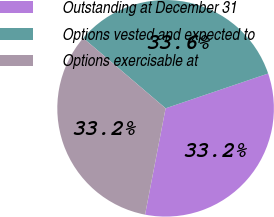Convert chart. <chart><loc_0><loc_0><loc_500><loc_500><pie_chart><fcel>Outstanding at December 31<fcel>Options vested and expected to<fcel>Options exercisable at<nl><fcel>33.24%<fcel>33.55%<fcel>33.2%<nl></chart> 